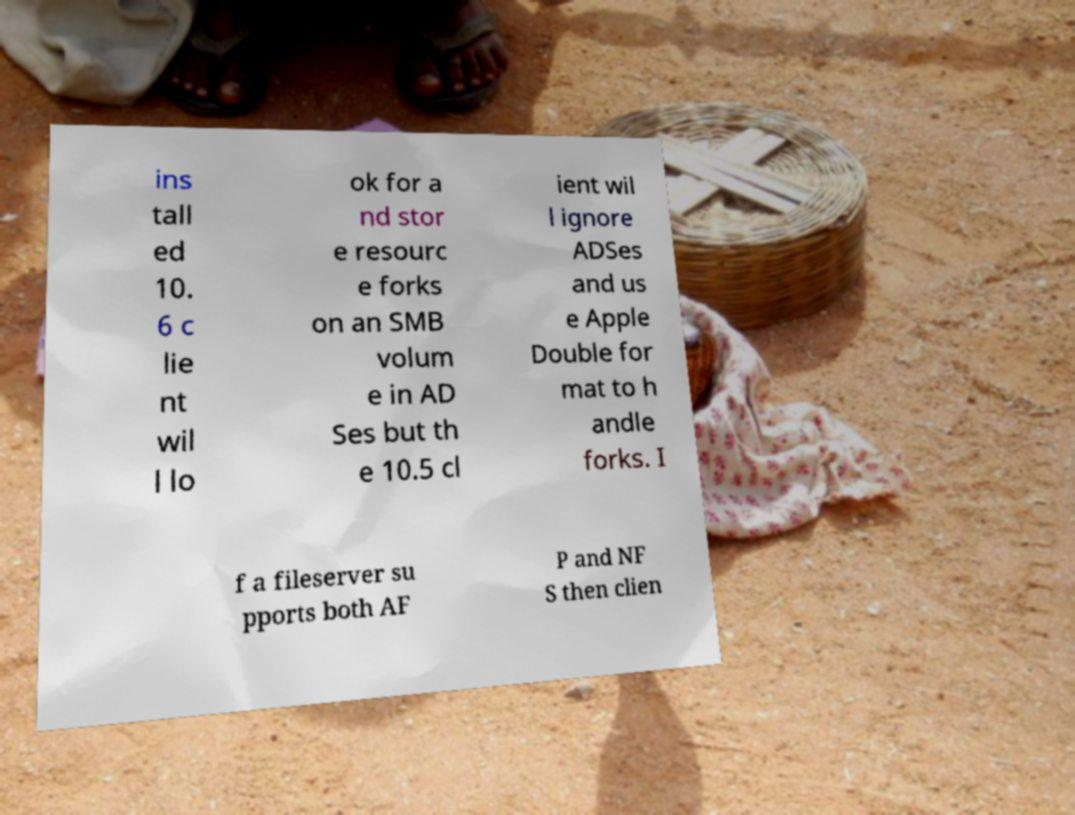Could you assist in decoding the text presented in this image and type it out clearly? ins tall ed 10. 6 c lie nt wil l lo ok for a nd stor e resourc e forks on an SMB volum e in AD Ses but th e 10.5 cl ient wil l ignore ADSes and us e Apple Double for mat to h andle forks. I f a fileserver su pports both AF P and NF S then clien 